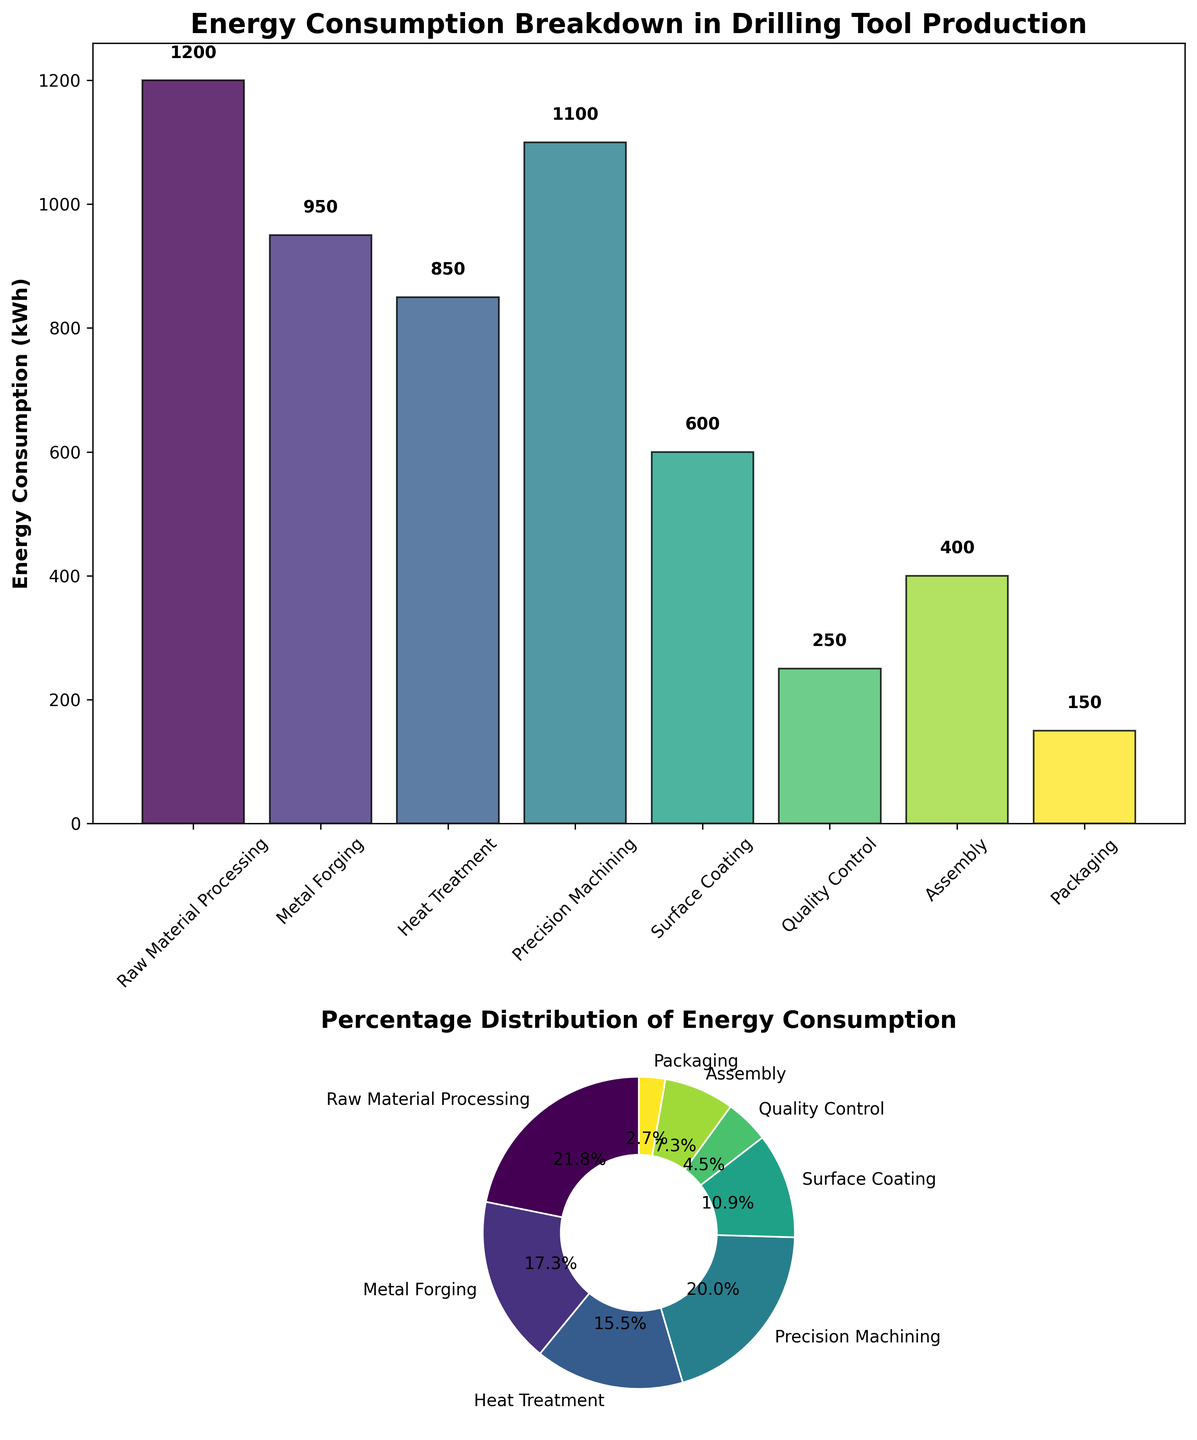How many stages are shown in the bar plot? Count the number of bars in the bar plot to determine the number of stages represented.
Answer: 8 Which stage has the highest energy consumption? Observe the height of the bars in the bar plot to find the tallest bar, indicating the highest energy consumption.
Answer: Raw Material Processing What percentage of the total energy consumption does Metal Forging contribute? Check the pie chart segment labeled Metal Forging and note the percentage value displayed.
Answer: 22.6% What is the combined energy consumption of Precision Machining and Heat Treatment? Add the energy consumption values of Precision Machining (1100 kWh) and Heat Treatment (850 kWh).
Answer: 1950 kWh How much more energy does Precision Machining consume compared to Surface Coating? Subtract the energy consumption of Surface Coating (600 kWh) from that of Precision Machining (1100 kWh).
Answer: 500 kWh Which stage has the least energy consumption? Find the smallest bar in the bar plot, indicating the minimum energy consumption stage.
Answer: Packaging What is the average energy consumption across all stages? Sum all energy consumption values (1200+950+850+1100+600+250+400+150) and divide by the number of stages (8).
Answer: 687.5 kWh If the energy consumption of Assembly and Packaging was combined into one stage, how would this new stage compare to the energy consumption of Heat Treatment? Combine the energy values of Assembly (400 kWh) and Packaging (150 kWh) to get 550 kWh, then compare it to Heat Treatment (850 kWh).
Answer: Assembly+Packaging would be 300 kWh less than Heat Treatment What is the total energy consumption for all the stages combined? Sum all the energy consumption values given for each stage.
Answer: 5500 kWh Which stages consume less than 500 kWh of energy? Identify bars in the bar plot that are lower than the 500 kWh mark and check their labels.
Answer: Quality Control, Assembly, Packaging 